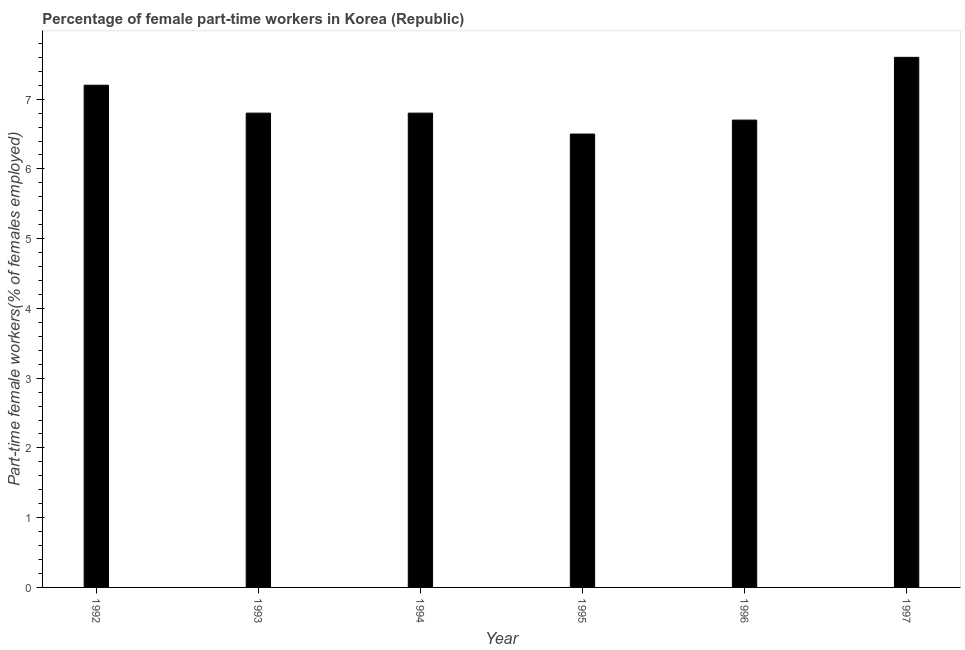Does the graph contain any zero values?
Make the answer very short. No. Does the graph contain grids?
Keep it short and to the point. No. What is the title of the graph?
Your answer should be compact. Percentage of female part-time workers in Korea (Republic). What is the label or title of the X-axis?
Keep it short and to the point. Year. What is the label or title of the Y-axis?
Keep it short and to the point. Part-time female workers(% of females employed). What is the percentage of part-time female workers in 1994?
Keep it short and to the point. 6.8. Across all years, what is the maximum percentage of part-time female workers?
Give a very brief answer. 7.6. Across all years, what is the minimum percentage of part-time female workers?
Your answer should be very brief. 6.5. In which year was the percentage of part-time female workers maximum?
Provide a short and direct response. 1997. What is the sum of the percentage of part-time female workers?
Provide a succinct answer. 41.6. What is the difference between the percentage of part-time female workers in 1993 and 1996?
Your answer should be compact. 0.1. What is the average percentage of part-time female workers per year?
Provide a succinct answer. 6.93. What is the median percentage of part-time female workers?
Make the answer very short. 6.8. Do a majority of the years between 1995 and 1996 (inclusive) have percentage of part-time female workers greater than 6.4 %?
Make the answer very short. Yes. What is the ratio of the percentage of part-time female workers in 1993 to that in 1996?
Offer a terse response. 1.01. Is the percentage of part-time female workers in 1992 less than that in 1997?
Offer a terse response. Yes. Is the sum of the percentage of part-time female workers in 1994 and 1995 greater than the maximum percentage of part-time female workers across all years?
Offer a very short reply. Yes. What is the difference between the highest and the lowest percentage of part-time female workers?
Ensure brevity in your answer.  1.1. In how many years, is the percentage of part-time female workers greater than the average percentage of part-time female workers taken over all years?
Provide a short and direct response. 2. How many bars are there?
Your answer should be very brief. 6. Are all the bars in the graph horizontal?
Offer a very short reply. No. What is the difference between two consecutive major ticks on the Y-axis?
Offer a terse response. 1. What is the Part-time female workers(% of females employed) of 1992?
Keep it short and to the point. 7.2. What is the Part-time female workers(% of females employed) of 1993?
Keep it short and to the point. 6.8. What is the Part-time female workers(% of females employed) in 1994?
Provide a short and direct response. 6.8. What is the Part-time female workers(% of females employed) of 1995?
Ensure brevity in your answer.  6.5. What is the Part-time female workers(% of females employed) in 1996?
Offer a terse response. 6.7. What is the Part-time female workers(% of females employed) of 1997?
Give a very brief answer. 7.6. What is the difference between the Part-time female workers(% of females employed) in 1992 and 1993?
Provide a succinct answer. 0.4. What is the difference between the Part-time female workers(% of females employed) in 1992 and 1994?
Provide a short and direct response. 0.4. What is the difference between the Part-time female workers(% of females employed) in 1992 and 1996?
Your answer should be compact. 0.5. What is the difference between the Part-time female workers(% of females employed) in 1993 and 1996?
Offer a terse response. 0.1. What is the difference between the Part-time female workers(% of females employed) in 1994 and 1995?
Your answer should be very brief. 0.3. What is the difference between the Part-time female workers(% of females employed) in 1994 and 1996?
Give a very brief answer. 0.1. What is the difference between the Part-time female workers(% of females employed) in 1994 and 1997?
Ensure brevity in your answer.  -0.8. What is the difference between the Part-time female workers(% of females employed) in 1995 and 1997?
Ensure brevity in your answer.  -1.1. What is the difference between the Part-time female workers(% of females employed) in 1996 and 1997?
Keep it short and to the point. -0.9. What is the ratio of the Part-time female workers(% of females employed) in 1992 to that in 1993?
Give a very brief answer. 1.06. What is the ratio of the Part-time female workers(% of females employed) in 1992 to that in 1994?
Keep it short and to the point. 1.06. What is the ratio of the Part-time female workers(% of females employed) in 1992 to that in 1995?
Offer a terse response. 1.11. What is the ratio of the Part-time female workers(% of females employed) in 1992 to that in 1996?
Offer a very short reply. 1.07. What is the ratio of the Part-time female workers(% of females employed) in 1992 to that in 1997?
Offer a very short reply. 0.95. What is the ratio of the Part-time female workers(% of females employed) in 1993 to that in 1995?
Keep it short and to the point. 1.05. What is the ratio of the Part-time female workers(% of females employed) in 1993 to that in 1997?
Your response must be concise. 0.9. What is the ratio of the Part-time female workers(% of females employed) in 1994 to that in 1995?
Give a very brief answer. 1.05. What is the ratio of the Part-time female workers(% of females employed) in 1994 to that in 1997?
Keep it short and to the point. 0.9. What is the ratio of the Part-time female workers(% of females employed) in 1995 to that in 1996?
Provide a short and direct response. 0.97. What is the ratio of the Part-time female workers(% of females employed) in 1995 to that in 1997?
Your answer should be very brief. 0.85. What is the ratio of the Part-time female workers(% of females employed) in 1996 to that in 1997?
Provide a short and direct response. 0.88. 